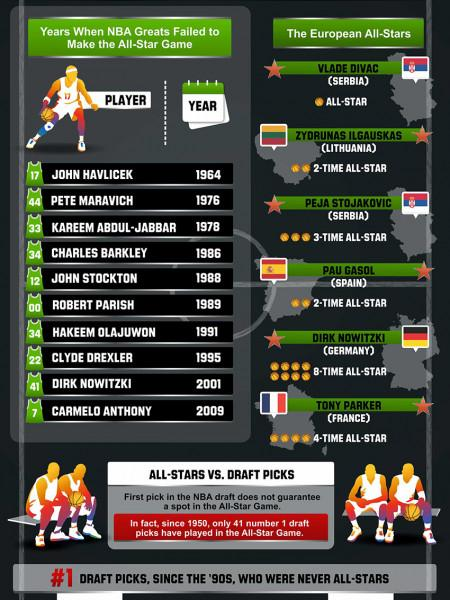Indicate a few pertinent items in this graphic. The 8-time All-Star player listed in this infographic is from Germany. In 2 All-Star games, Lithuanian basketball player Zydrunas Ilgauskas played, showcasing his impressive skills and talent. The name of the NBA player who is listed seventh in the list is Hakeem Olajuwon. The name of Kareem Abdul-Jabbar, who is third among the list of NBA players, is known. 2 out of the European All-Stars are from Serbia. 